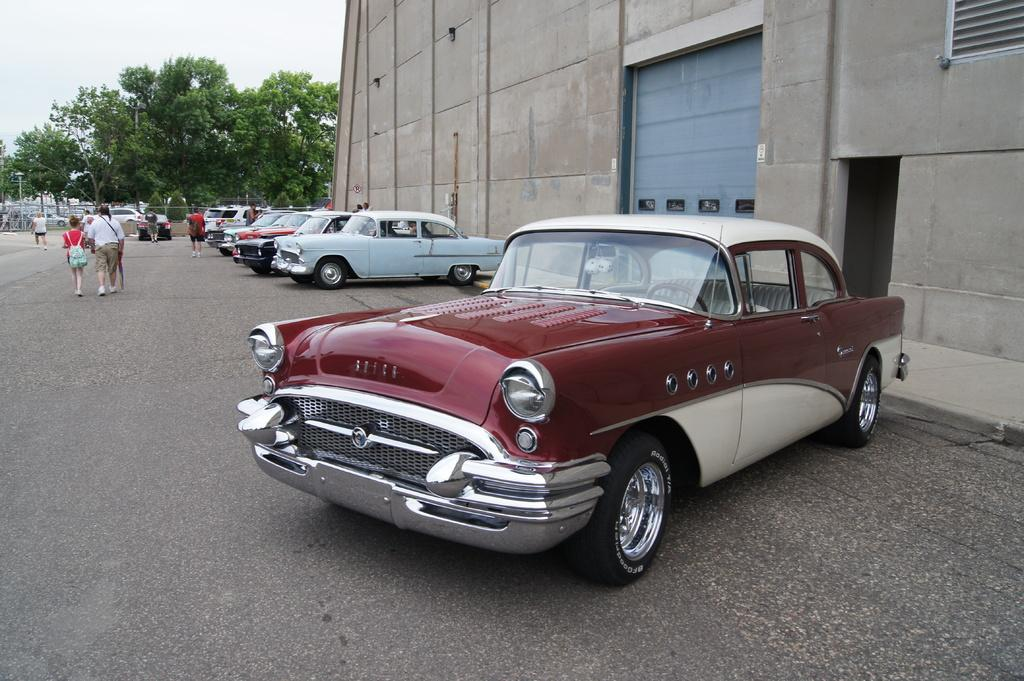What can be seen on the road in the image? There are vehicles and people on the road in the image. What is located on the right side of the image? There is a building on the right side of the image. What type of natural elements can be seen in the background of the image? There are trees visible in the background of the image. What scent can be detected from the image? There is no information about scents in the image, as it is a visual representation. How many clouds are visible in the image? There is no mention of clouds in the image; it only shows vehicles, people, a building, and trees. 